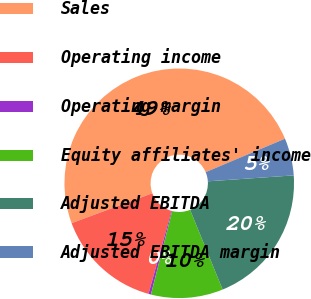<chart> <loc_0><loc_0><loc_500><loc_500><pie_chart><fcel>Sales<fcel>Operating income<fcel>Operating margin<fcel>Equity affiliates' income<fcel>Adjusted EBITDA<fcel>Adjusted EBITDA margin<nl><fcel>49.3%<fcel>15.04%<fcel>0.35%<fcel>10.14%<fcel>19.93%<fcel>5.25%<nl></chart> 